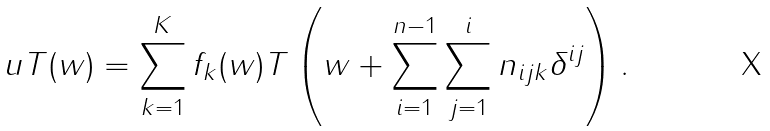Convert formula to latex. <formula><loc_0><loc_0><loc_500><loc_500>u T ( w ) = \sum _ { k = 1 } ^ { K } f _ { k } ( w ) T \left ( w + \sum _ { i = 1 } ^ { n - 1 } \sum _ { j = 1 } ^ { i } n _ { i j k } \delta ^ { i j } \right ) .</formula> 